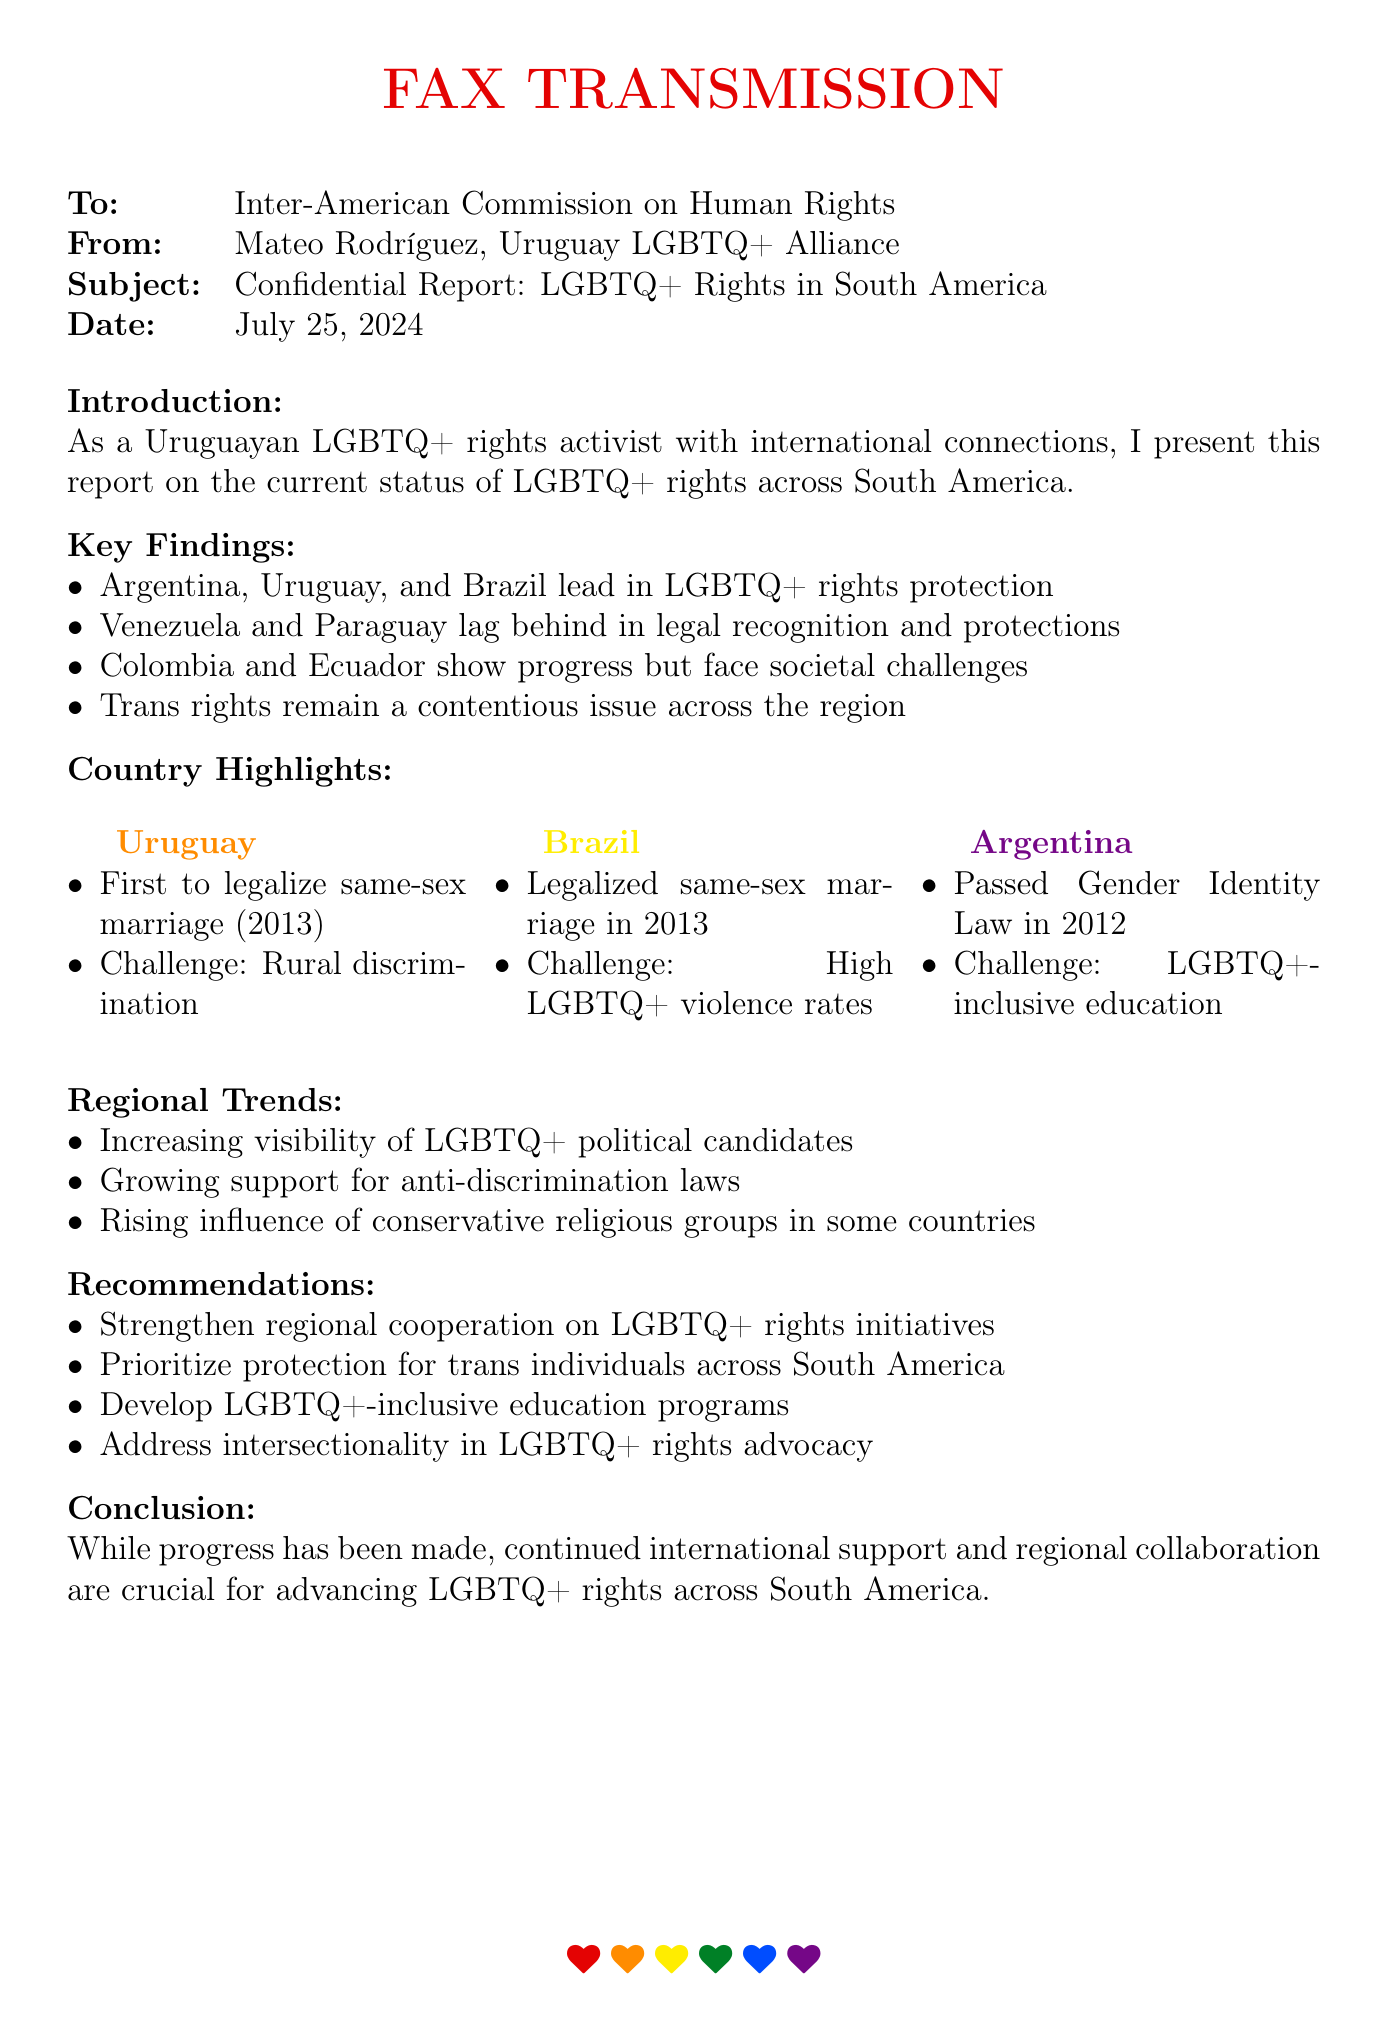what is the subject of the fax? The subject of the fax is the focus of the communication, which is a Confidential Report on LGBTQ+ Rights in South America.
Answer: Confidential Report: LGBTQ+ Rights in South America who is the sender of the document? The sender of the document is specified in the fax header, identifying Mateo Rodríguez as the representative of the Uruguay LGBTQ+ Alliance.
Answer: Mateo Rodríguez, Uruguay LGBTQ+ Alliance which country was the first to legalize same-sex marriage? The document states that Uruguay was the first country to legalize same-sex marriage in 2013.
Answer: Uruguay what year did Argentina pass the Gender Identity Law? The year mentioned in the report for when Argentina passed the Gender Identity Law is 2012.
Answer: 2012 what is one of the challenges faced by Brazil regarding LGBTQ+ rights? The document highlights that a significant challenge faced by Brazil is the high rates of violence against LGBTQ+ individuals.
Answer: High LGBTQ+ violence rates which countries are recognized as lagging behind in legal recognition and protections? The report specifies Venezuela and Paraguay as the countries lagging behind in legal recognition and protections for LGBTQ+ rights.
Answer: Venezuela and Paraguay what does the report recommend prioritizing across South America? The report recommends prioritizing the protection of trans individuals across South America as a key action point.
Answer: Protection for trans individuals what trend is noted regarding LGBTQ+ political candidates in the region? The report notes an increasing visibility of LGBTQ+ political candidates as a positive trend in the region.
Answer: Increasing visibility how many countries are mentioned in the key findings that lead in LGBTQ+ rights protection? The document mentions three countries leading in LGBTQ+ rights protection: Argentina, Uruguay, and Brazil.
Answer: Three 